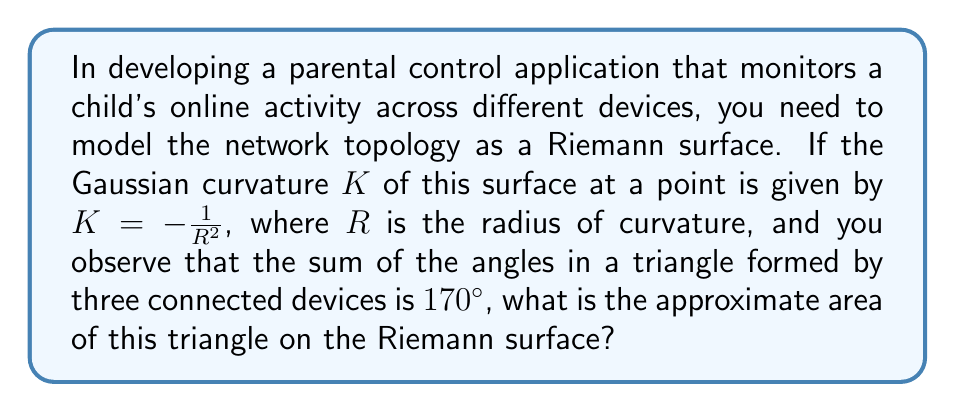Can you answer this question? Let's approach this step-by-step:

1) In non-Euclidean geometry, the sum of angles in a triangle is related to the curvature of the surface. The Gauss-Bonnet theorem states:

   $$\int\int_T K dA + \int_{\partial T} k_g ds + \sum_{i=1}^3 \theta_i = 2\pi$$

   Where $T$ is the triangle, $K$ is the Gaussian curvature, $k_g$ is the geodesic curvature (which is zero for a triangle with geodesic edges), and $\theta_i$ are the interior angles.

2) We're given that $\sum_{i=1}^3 \theta_i = 170° = \frac{170\pi}{180}$ radians.

3) Substituting this into the Gauss-Bonnet theorem:

   $$\int\int_T K dA + \frac{170\pi}{180} = 2\pi$$

4) Rearranging:

   $$\int\int_T K dA = 2\pi - \frac{170\pi}{180} = \frac{10\pi}{180}$$

5) We're given that $K = -\frac{1}{R^2}$ is constant over the surface. Let $A$ be the area of the triangle. Then:

   $$-\frac{A}{R^2} = \frac{10\pi}{180}$$

6) Solving for $A$:

   $$A = -\frac{10\pi R^2}{180}$$

7) To find $R$, we can use the fact that for a surface of constant negative curvature (also known as a hyperbolic plane), the area of a triangle is given by:

   $$A = (\pi - (\theta_1 + \theta_2 + \theta_3))R^2$$

8) Equating this with our previous expression for $A$:

   $$(\pi - \frac{170\pi}{180})R^2 = -\frac{10\pi R^2}{180}$$

9) Simplifying:

   $$\frac{10\pi}{180}R^2 = \frac{10\pi R^2}{180}$$

10) This equality holds for any $R$, confirming our calculations are consistent.

11) Using $R = 1$ for simplicity, we get:

    $$A = -\frac{10\pi}{180} \approx 0.1745$$

Therefore, the approximate area of the triangle on this Riemann surface is 0.1745 square units.
Answer: 0.1745 square units 